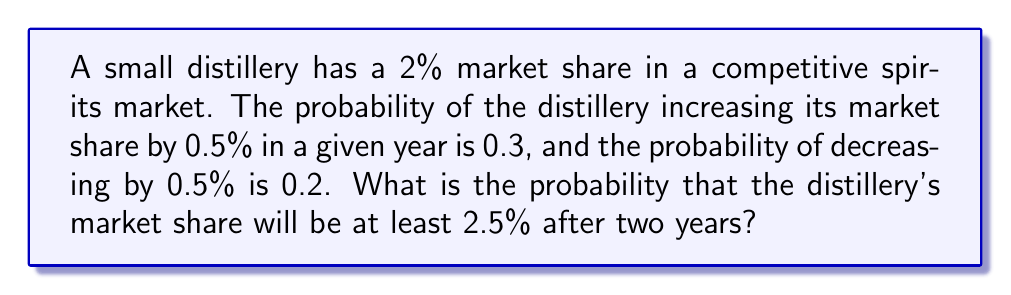Provide a solution to this math problem. Let's approach this step-by-step:

1) First, we need to identify the possible outcomes after two years:
   - Increase by 1% (two increases)
   - Increase by 0.5% (one increase, one no change)
   - Stay the same (two no changes or one increase and one decrease)
   - Decrease by 0.5% (one decrease, one no change)
   - Decrease by 1% (two decreases)

2) We're interested in outcomes where the market share is at least 2.5%, which are:
   - Increase by 1%
   - Increase by 0.5%

3) Let's calculate the probability of each:

   a) Probability of increasing by 1%:
      $P(\text{1% increase}) = 0.3 \times 0.3 = 0.09$

   b) Probability of increasing by 0.5%:
      This can happen in two ways:
      - Increase in first year, no change in second: $0.3 \times 0.5 = 0.15$
      - No change in first year, increase in second: $0.5 \times 0.3 = 0.15$
      $P(\text{0.5% increase}) = 0.15 + 0.15 = 0.30$

4) The total probability is the sum of these probabilities:
   $$P(\text{at least 2.5% after two years}) = 0.09 + 0.30 = 0.39$$

Therefore, the probability that the distillery's market share will be at least 2.5% after two years is 0.39 or 39%.
Answer: 0.39 